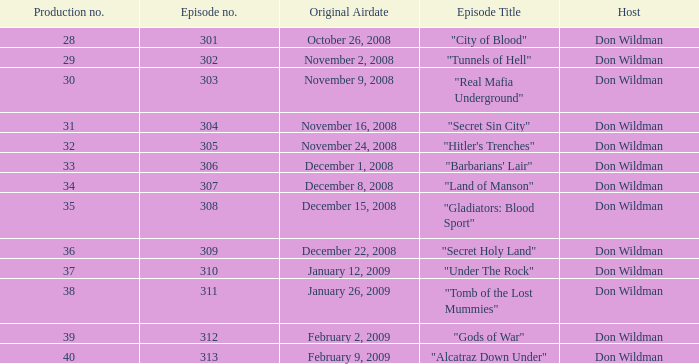Which episode, with a production number less than 38, first aired on january 26, 2009? 0.0. 